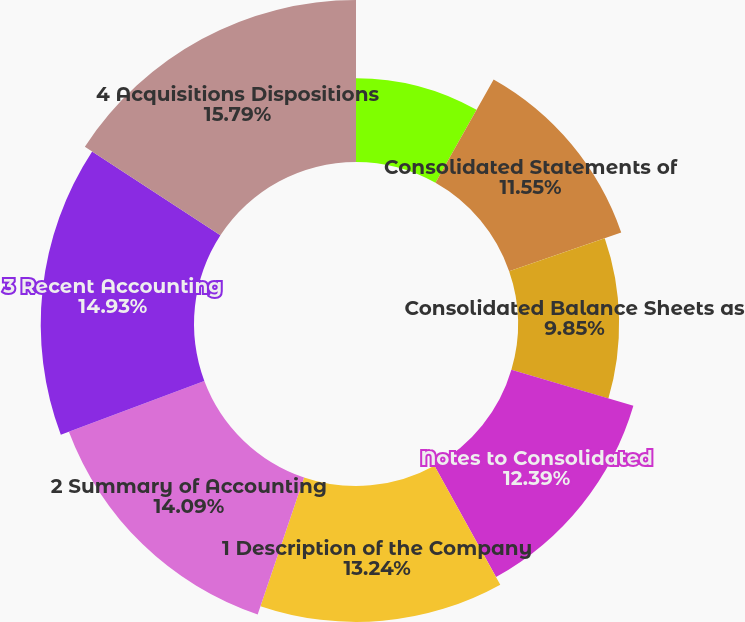<chart> <loc_0><loc_0><loc_500><loc_500><pie_chart><fcel>Report of Independent<fcel>Consolidated Statements of<fcel>Consolidated Balance Sheets as<fcel>Notes to Consolidated<fcel>1 Description of the Company<fcel>2 Summary of Accounting<fcel>3 Recent Accounting<fcel>4 Acquisitions Dispositions<nl><fcel>8.16%<fcel>11.55%<fcel>9.85%<fcel>12.39%<fcel>13.24%<fcel>14.09%<fcel>14.93%<fcel>15.78%<nl></chart> 